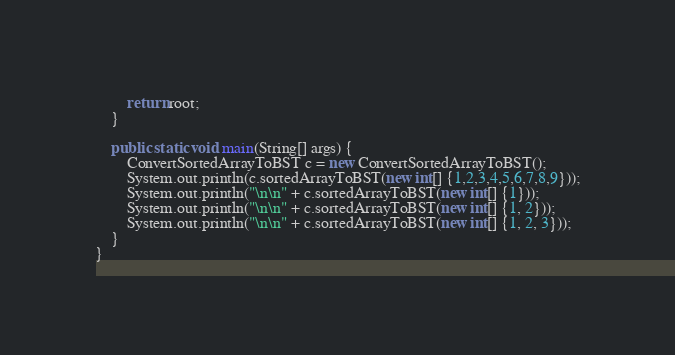Convert code to text. <code><loc_0><loc_0><loc_500><loc_500><_Java_>        return root;
    }

    public static void main(String[] args) {
        ConvertSortedArrayToBST c = new ConvertSortedArrayToBST();
        System.out.println(c.sortedArrayToBST(new int[] {1,2,3,4,5,6,7,8,9}));
        System.out.println("\n\n" + c.sortedArrayToBST(new int[] {1}));
        System.out.println("\n\n" + c.sortedArrayToBST(new int[] {1, 2}));
        System.out.println("\n\n" + c.sortedArrayToBST(new int[] {1, 2, 3}));
    }
}
</code> 